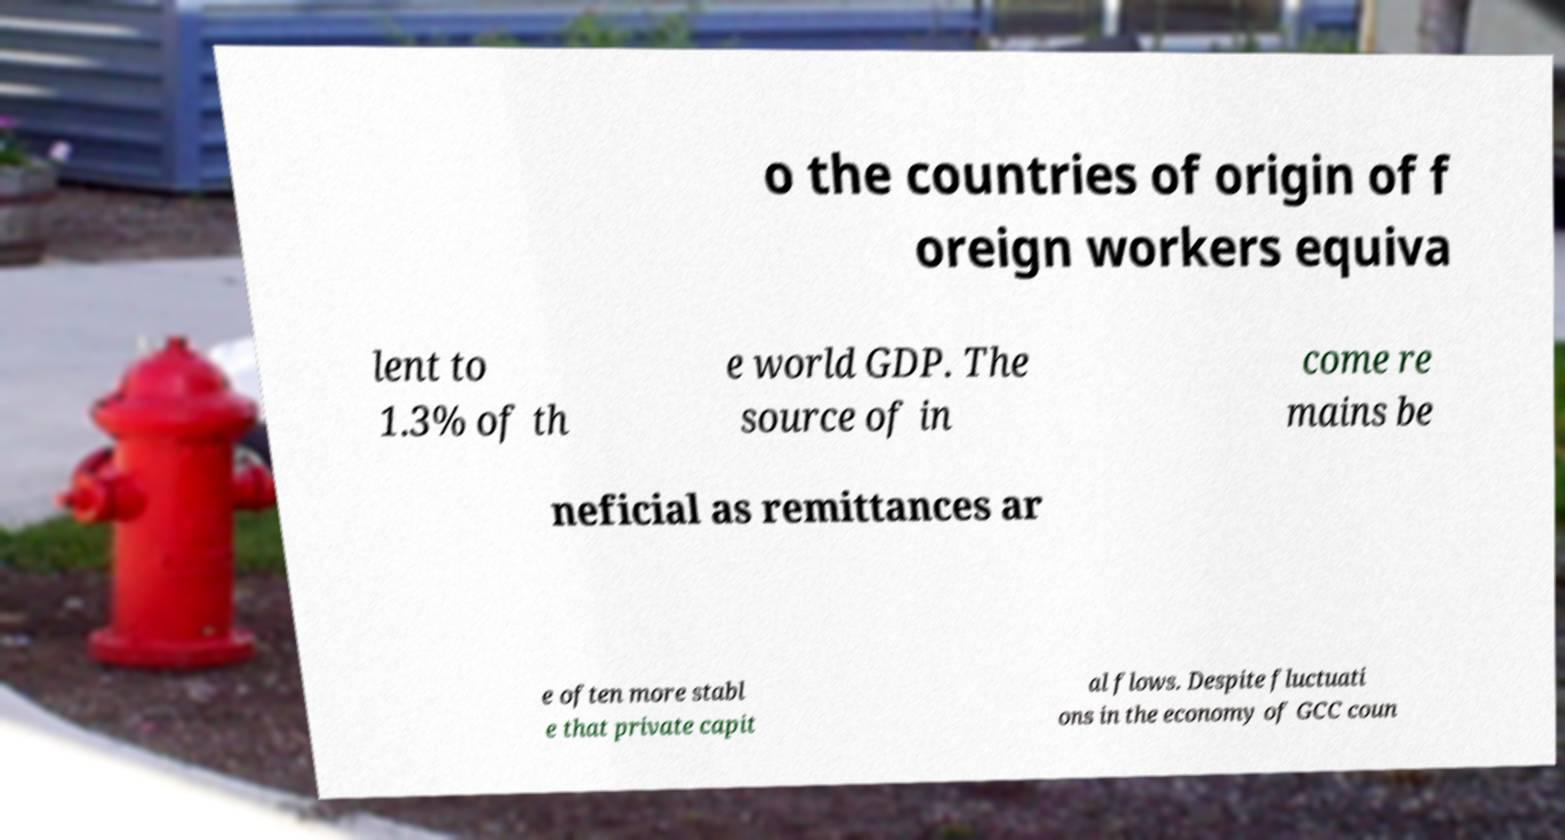Could you assist in decoding the text presented in this image and type it out clearly? o the countries of origin of f oreign workers equiva lent to 1.3% of th e world GDP. The source of in come re mains be neficial as remittances ar e often more stabl e that private capit al flows. Despite fluctuati ons in the economy of GCC coun 